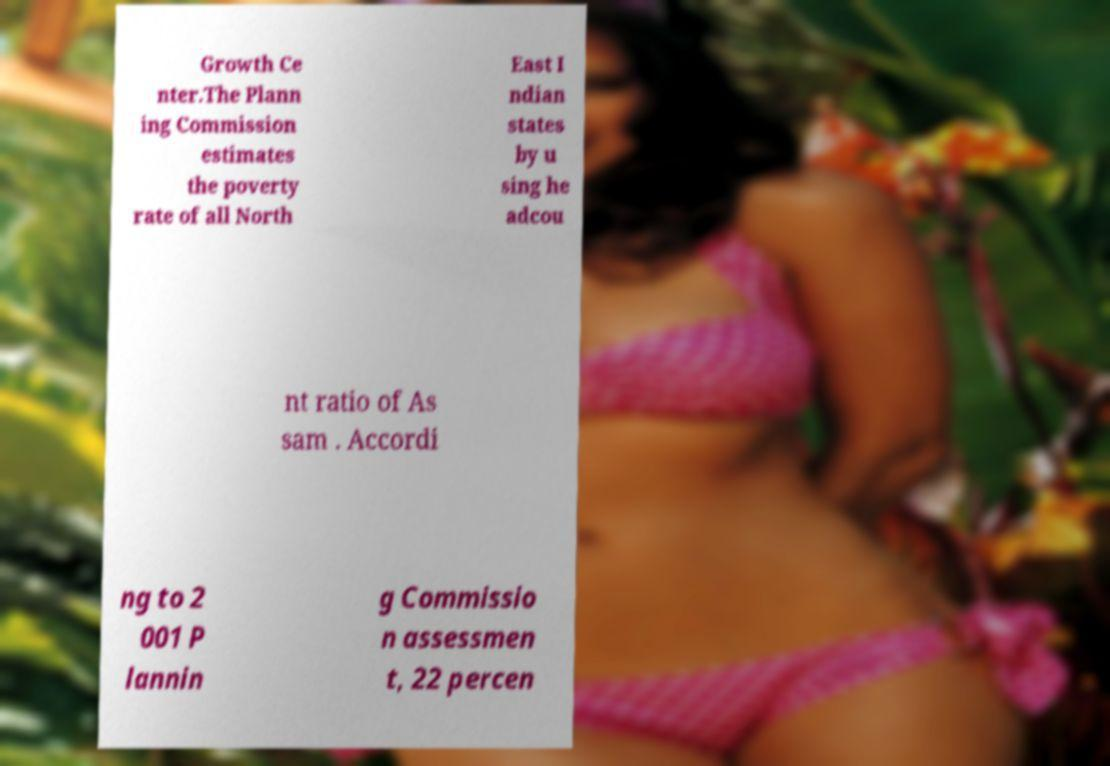Could you extract and type out the text from this image? Growth Ce nter.The Plann ing Commission estimates the poverty rate of all North East I ndian states by u sing he adcou nt ratio of As sam . Accordi ng to 2 001 P lannin g Commissio n assessmen t, 22 percen 